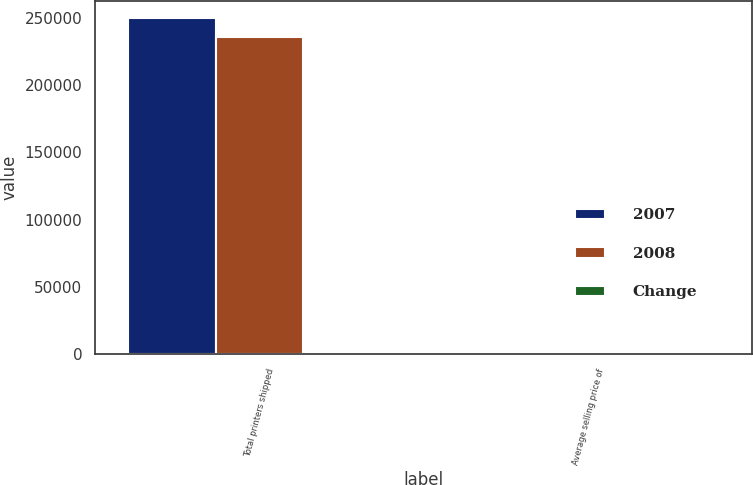<chart> <loc_0><loc_0><loc_500><loc_500><stacked_bar_chart><ecel><fcel>Total printers shipped<fcel>Average selling price of<nl><fcel>2007<fcel>249902<fcel>538<nl><fcel>2008<fcel>235267<fcel>600<nl><fcel>Change<fcel>6.2<fcel>10.3<nl></chart> 